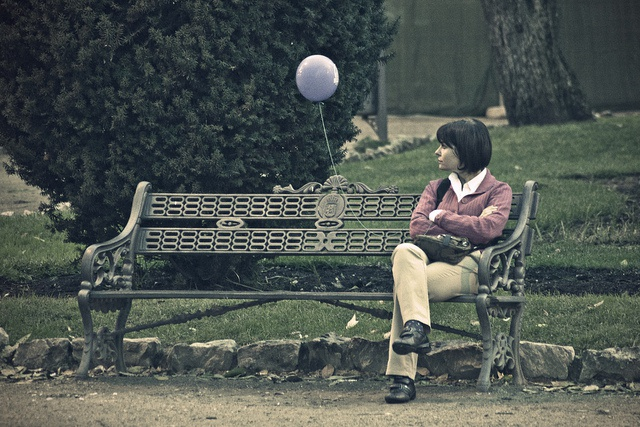Describe the objects in this image and their specific colors. I can see bench in black, gray, darkgray, and purple tones, people in black, gray, darkgray, and tan tones, and handbag in black, gray, and purple tones in this image. 